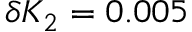Convert formula to latex. <formula><loc_0><loc_0><loc_500><loc_500>\delta { K _ { 2 } } = 0 . 0 0 5</formula> 